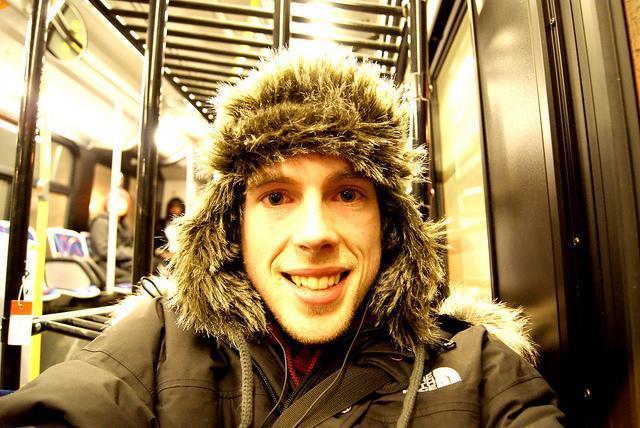How many people are there?
Give a very brief answer. 2. 